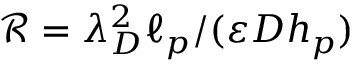<formula> <loc_0><loc_0><loc_500><loc_500>\mathcal { R } = \lambda _ { D } ^ { 2 } \ell _ { p } / ( \varepsilon D h _ { p } )</formula> 